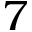Convert formula to latex. <formula><loc_0><loc_0><loc_500><loc_500>7</formula> 